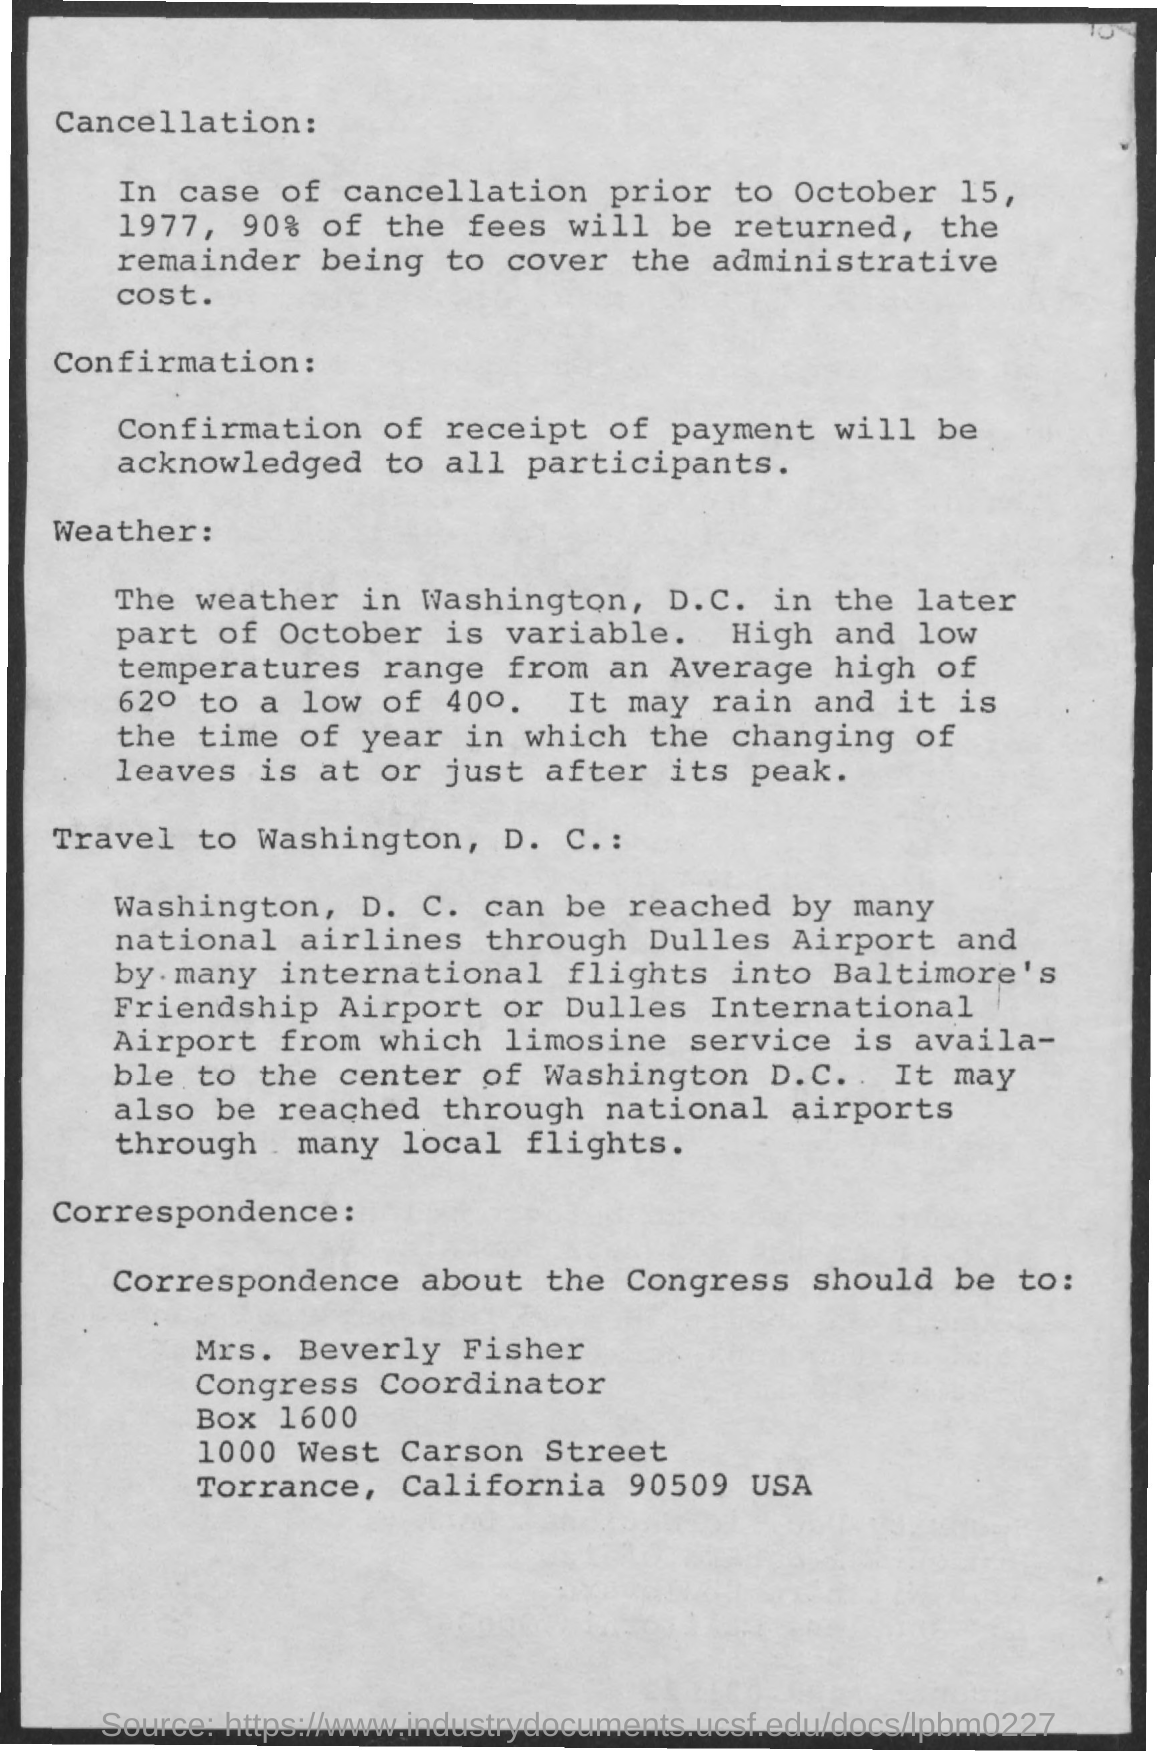How much fee percentage will be returned in case of cancellation prior to October 15,1977?
Your answer should be very brief. 90%. 